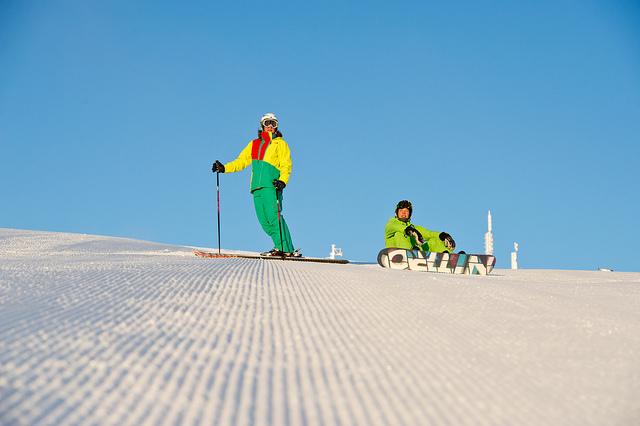What is he wearing?
Be succinct. Snowsuit. What color are the persons pance?
Keep it brief. Green. Is there a man flying through the air?
Give a very brief answer. No. What is this person riding?
Keep it brief. Skis. Is this person going slowly down the hill?
Answer briefly. Yes. What color is the Man's Jacket?
Give a very brief answer. Yellow. What brand is the snowboard?
Write a very short answer. Calling. 